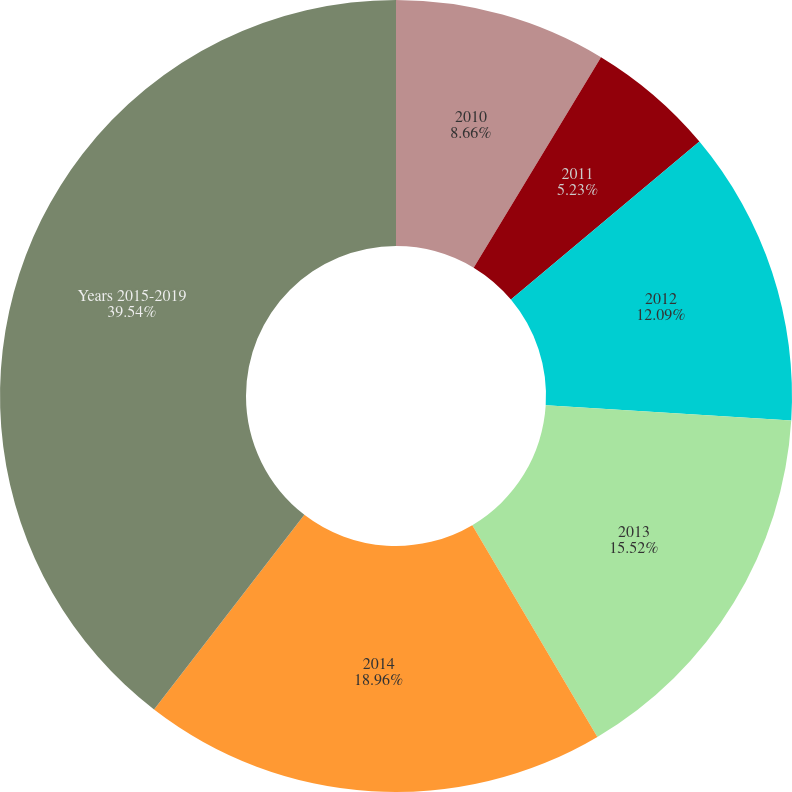<chart> <loc_0><loc_0><loc_500><loc_500><pie_chart><fcel>2010<fcel>2011<fcel>2012<fcel>2013<fcel>2014<fcel>Years 2015-2019<nl><fcel>8.66%<fcel>5.23%<fcel>12.09%<fcel>15.52%<fcel>18.95%<fcel>39.53%<nl></chart> 